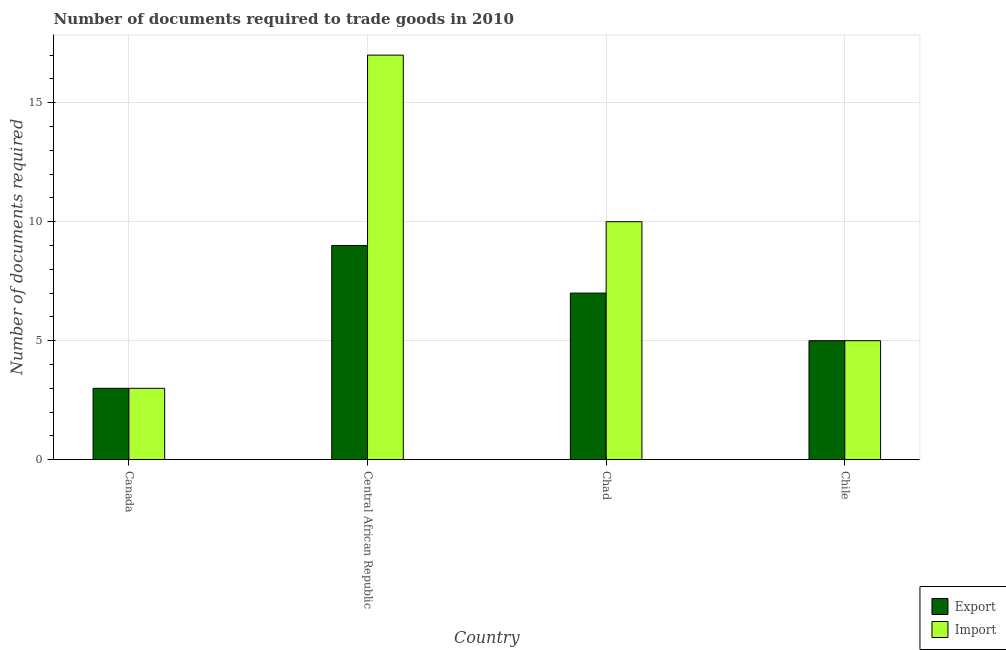How many groups of bars are there?
Ensure brevity in your answer.  4. Are the number of bars per tick equal to the number of legend labels?
Give a very brief answer. Yes. Are the number of bars on each tick of the X-axis equal?
Provide a short and direct response. Yes. How many bars are there on the 3rd tick from the right?
Offer a terse response. 2. What is the label of the 3rd group of bars from the left?
Offer a terse response. Chad. Across all countries, what is the maximum number of documents required to export goods?
Your answer should be compact. 9. In which country was the number of documents required to import goods maximum?
Keep it short and to the point. Central African Republic. What is the difference between the number of documents required to import goods and number of documents required to export goods in Central African Republic?
Give a very brief answer. 8. Is the number of documents required to export goods in Canada less than that in Chad?
Offer a terse response. Yes. What is the difference between the highest and the lowest number of documents required to export goods?
Your answer should be compact. 6. What does the 1st bar from the left in Central African Republic represents?
Make the answer very short. Export. What does the 2nd bar from the right in Central African Republic represents?
Your response must be concise. Export. What is the difference between two consecutive major ticks on the Y-axis?
Your answer should be very brief. 5. Does the graph contain grids?
Keep it short and to the point. Yes. Where does the legend appear in the graph?
Your answer should be very brief. Bottom right. What is the title of the graph?
Your response must be concise. Number of documents required to trade goods in 2010. What is the label or title of the Y-axis?
Your response must be concise. Number of documents required. What is the Number of documents required in Import in Canada?
Your answer should be compact. 3. What is the Number of documents required of Export in Central African Republic?
Keep it short and to the point. 9. What is the Number of documents required in Import in Central African Republic?
Offer a terse response. 17. What is the Number of documents required in Export in Chad?
Your response must be concise. 7. What is the Number of documents required in Import in Chad?
Your answer should be very brief. 10. What is the Number of documents required of Import in Chile?
Provide a short and direct response. 5. Across all countries, what is the maximum Number of documents required of Export?
Offer a very short reply. 9. Across all countries, what is the minimum Number of documents required in Import?
Provide a short and direct response. 3. What is the total Number of documents required in Export in the graph?
Offer a very short reply. 24. What is the difference between the Number of documents required of Export in Canada and that in Chad?
Provide a succinct answer. -4. What is the difference between the Number of documents required of Export in Chad and that in Chile?
Make the answer very short. 2. What is the difference between the Number of documents required in Import in Chad and that in Chile?
Give a very brief answer. 5. What is the average Number of documents required of Import per country?
Your answer should be very brief. 8.75. What is the difference between the Number of documents required in Export and Number of documents required in Import in Canada?
Your answer should be very brief. 0. What is the ratio of the Number of documents required in Export in Canada to that in Central African Republic?
Give a very brief answer. 0.33. What is the ratio of the Number of documents required of Import in Canada to that in Central African Republic?
Ensure brevity in your answer.  0.18. What is the ratio of the Number of documents required of Export in Canada to that in Chad?
Provide a succinct answer. 0.43. What is the ratio of the Number of documents required of Import in Canada to that in Chile?
Your answer should be compact. 0.6. What is the ratio of the Number of documents required of Import in Central African Republic to that in Chile?
Provide a short and direct response. 3.4. What is the ratio of the Number of documents required of Export in Chad to that in Chile?
Make the answer very short. 1.4. What is the ratio of the Number of documents required of Import in Chad to that in Chile?
Make the answer very short. 2. What is the difference between the highest and the lowest Number of documents required in Export?
Your answer should be very brief. 6. What is the difference between the highest and the lowest Number of documents required of Import?
Provide a succinct answer. 14. 